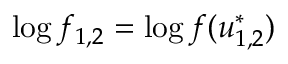<formula> <loc_0><loc_0><loc_500><loc_500>\log f _ { 1 , 2 } = \log f ( u _ { 1 , 2 } ^ { * } )</formula> 